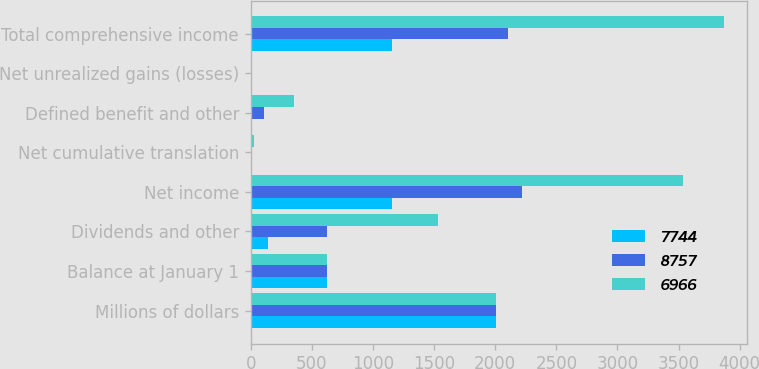<chart> <loc_0><loc_0><loc_500><loc_500><stacked_bar_chart><ecel><fcel>Millions of dollars<fcel>Balance at January 1<fcel>Dividends and other<fcel>Net income<fcel>Net cumulative translation<fcel>Defined benefit and other<fcel>Net unrealized gains (losses)<fcel>Total comprehensive income<nl><fcel>7744<fcel>2009<fcel>623<fcel>144<fcel>1155<fcel>5<fcel>2<fcel>5<fcel>1157<nl><fcel>8757<fcel>2008<fcel>623<fcel>623<fcel>2215<fcel>1<fcel>106<fcel>6<fcel>2104<nl><fcel>6966<fcel>2007<fcel>623<fcel>1529<fcel>3536<fcel>23<fcel>355<fcel>1<fcel>3869<nl></chart> 